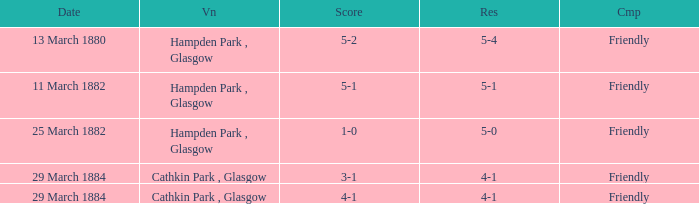Which competition had a 4-1 result, and a score of 4-1? Friendly. 